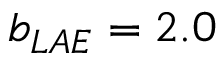Convert formula to latex. <formula><loc_0><loc_0><loc_500><loc_500>b _ { L A E } = 2 . 0</formula> 